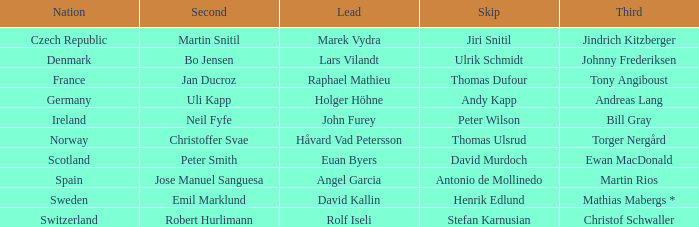In which third did angel garcia lead? Martin Rios. 